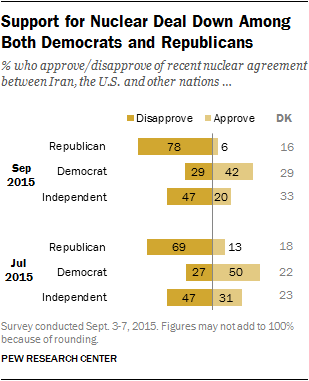Point out several critical features in this image. The Republican party is more likely to choose disapproval. The approval rating of Republicans is larger than the disapproval rating of both Democrats and Independents combined. 